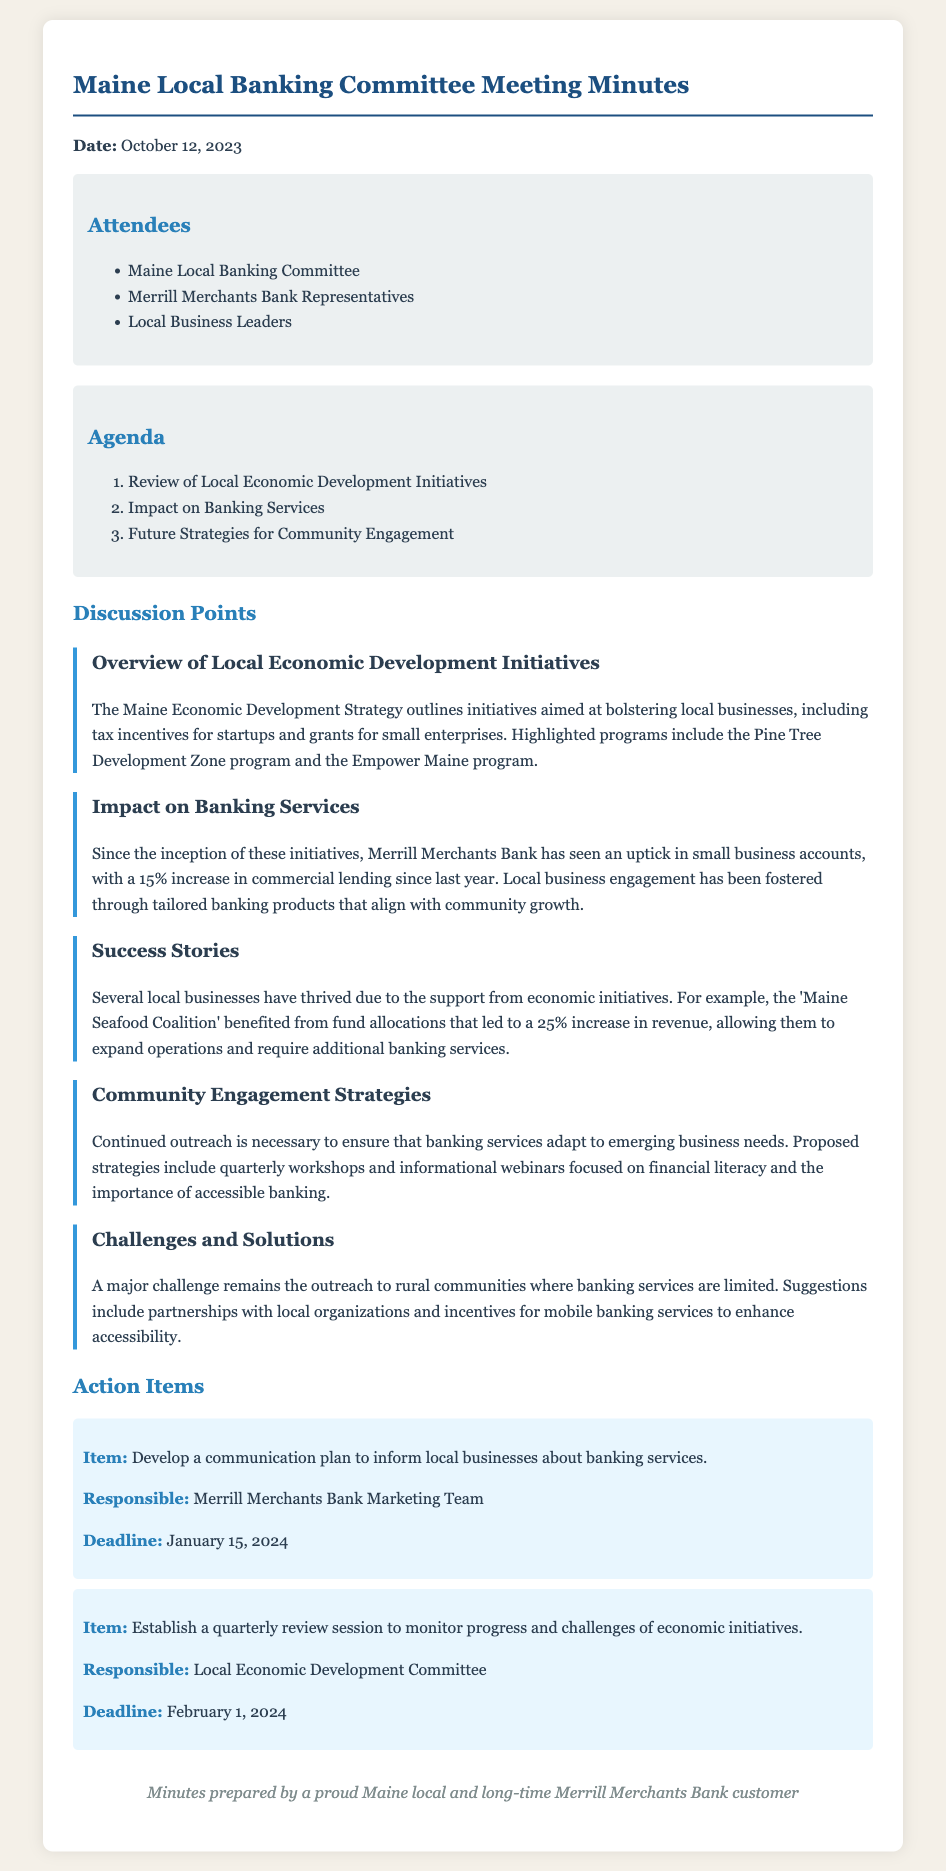what date did the meeting take place? The date of the meeting is explicitly mentioned at the beginning of the document.
Answer: October 12, 2023 who is responsible for developing a communication plan? This information is located in the action items section, specifying which team is responsible for the task.
Answer: Merrill Merchants Bank Marketing Team what has been the percentage increase in commercial lending? The document states the percentage increase in commercial lending since last year, detailing its significant growth.
Answer: 15% which economic initiative led to a 25% increase in revenue for a local business? This question refers to the specific example given in the success stories section, identifying the initiative that benefitted that business.
Answer: Maine Seafood Coalition what is one proposed strategy for community engagement? The document lists strategies aimed at improving community engagement, highlighting key actions proposed in the discussion.
Answer: Quarterly workshops what challenge is mentioned regarding rural communities? This question addresses a specific challenge noted in the challenges and solutions discussion point concerning banking services.
Answer: Limited banking services what is one of the initiatives mentioned in the Overview of Local Economic Development Initiatives? The document provides specific names of initiatives discussed in the overview section focused on local economic growth.
Answer: Pine Tree Development Zone program when is the deadline for the quarterly review session? This information is found in the action items section, indicating the deadline for the established review session.
Answer: February 1, 2024 